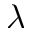Convert formula to latex. <formula><loc_0><loc_0><loc_500><loc_500>\lambda</formula> 